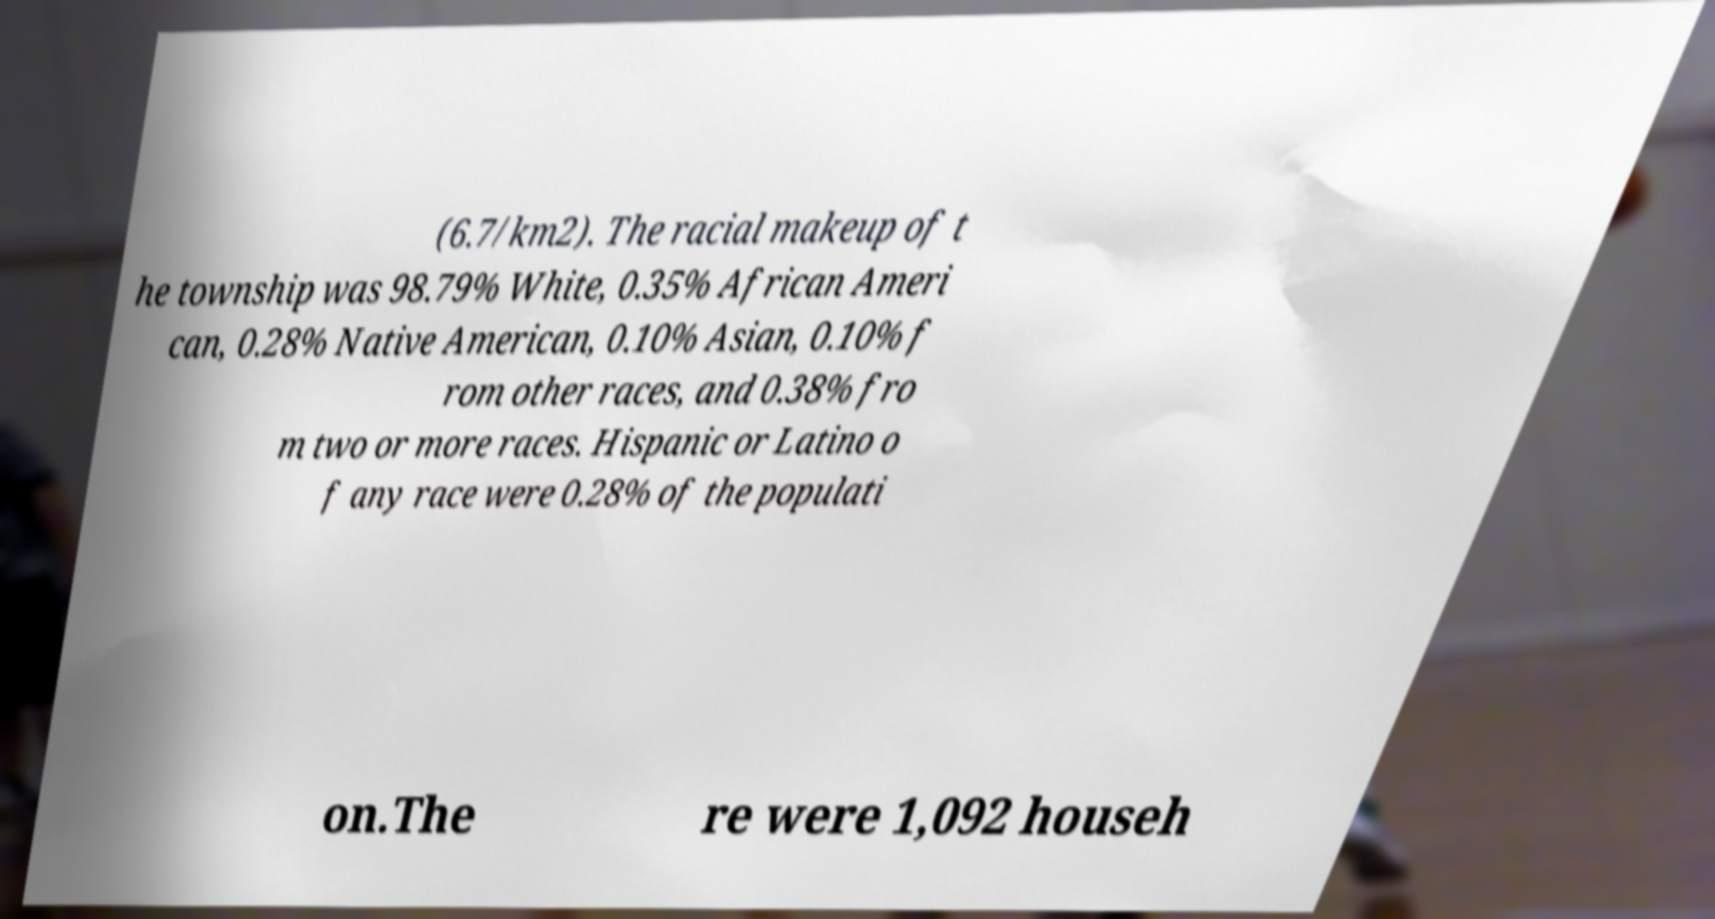Please identify and transcribe the text found in this image. (6.7/km2). The racial makeup of t he township was 98.79% White, 0.35% African Ameri can, 0.28% Native American, 0.10% Asian, 0.10% f rom other races, and 0.38% fro m two or more races. Hispanic or Latino o f any race were 0.28% of the populati on.The re were 1,092 househ 